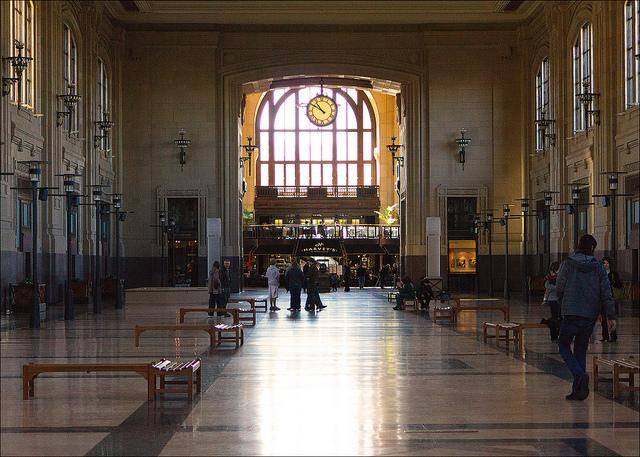What is on the left side of the room?

Choices:
A) barrel
B) wheelbarrow
C) bench
D) apple cart bench 